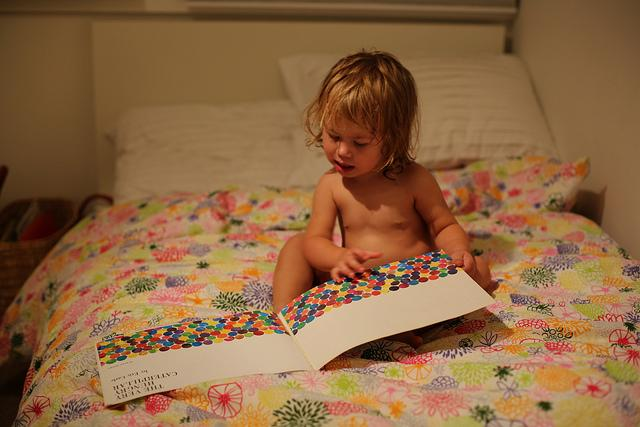On what does the child focus here? Please explain your reasoning. dots. The child is looking at multi-colored circles on the paper in front of him. 